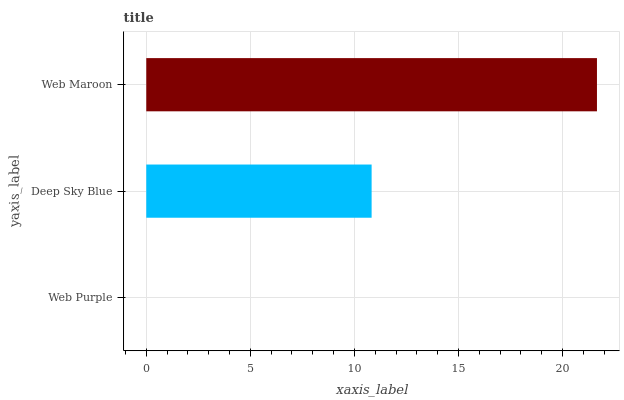Is Web Purple the minimum?
Answer yes or no. Yes. Is Web Maroon the maximum?
Answer yes or no. Yes. Is Deep Sky Blue the minimum?
Answer yes or no. No. Is Deep Sky Blue the maximum?
Answer yes or no. No. Is Deep Sky Blue greater than Web Purple?
Answer yes or no. Yes. Is Web Purple less than Deep Sky Blue?
Answer yes or no. Yes. Is Web Purple greater than Deep Sky Blue?
Answer yes or no. No. Is Deep Sky Blue less than Web Purple?
Answer yes or no. No. Is Deep Sky Blue the high median?
Answer yes or no. Yes. Is Deep Sky Blue the low median?
Answer yes or no. Yes. Is Web Maroon the high median?
Answer yes or no. No. Is Web Maroon the low median?
Answer yes or no. No. 